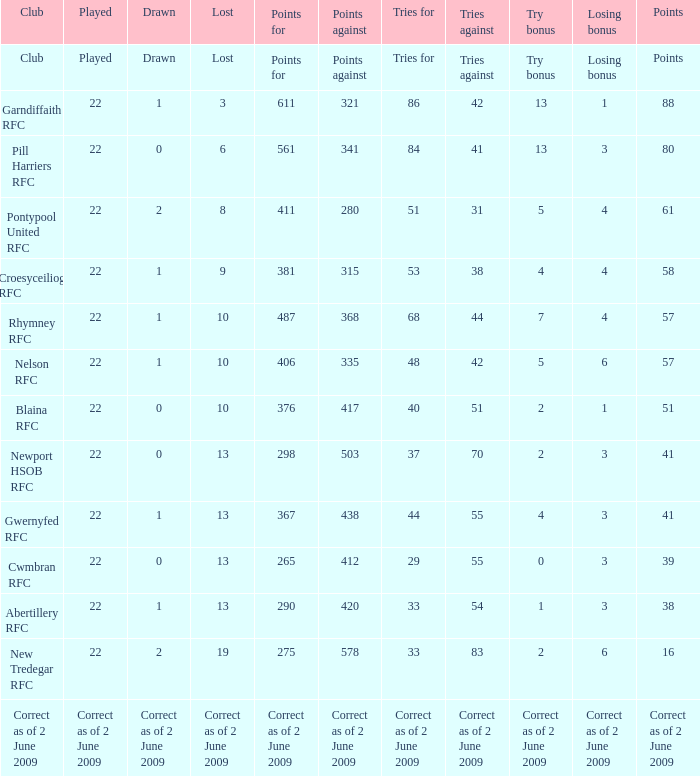How many points against did the club with a losing bonus of 3 and 84 tries have? 341.0. Parse the table in full. {'header': ['Club', 'Played', 'Drawn', 'Lost', 'Points for', 'Points against', 'Tries for', 'Tries against', 'Try bonus', 'Losing bonus', 'Points'], 'rows': [['Club', 'Played', 'Drawn', 'Lost', 'Points for', 'Points against', 'Tries for', 'Tries against', 'Try bonus', 'Losing bonus', 'Points'], ['Garndiffaith RFC', '22', '1', '3', '611', '321', '86', '42', '13', '1', '88'], ['Pill Harriers RFC', '22', '0', '6', '561', '341', '84', '41', '13', '3', '80'], ['Pontypool United RFC', '22', '2', '8', '411', '280', '51', '31', '5', '4', '61'], ['Croesyceiliog RFC', '22', '1', '9', '381', '315', '53', '38', '4', '4', '58'], ['Rhymney RFC', '22', '1', '10', '487', '368', '68', '44', '7', '4', '57'], ['Nelson RFC', '22', '1', '10', '406', '335', '48', '42', '5', '6', '57'], ['Blaina RFC', '22', '0', '10', '376', '417', '40', '51', '2', '1', '51'], ['Newport HSOB RFC', '22', '0', '13', '298', '503', '37', '70', '2', '3', '41'], ['Gwernyfed RFC', '22', '1', '13', '367', '438', '44', '55', '4', '3', '41'], ['Cwmbran RFC', '22', '0', '13', '265', '412', '29', '55', '0', '3', '39'], ['Abertillery RFC', '22', '1', '13', '290', '420', '33', '54', '1', '3', '38'], ['New Tredegar RFC', '22', '2', '19', '275', '578', '33', '83', '2', '6', '16'], ['Correct as of 2 June 2009', 'Correct as of 2 June 2009', 'Correct as of 2 June 2009', 'Correct as of 2 June 2009', 'Correct as of 2 June 2009', 'Correct as of 2 June 2009', 'Correct as of 2 June 2009', 'Correct as of 2 June 2009', 'Correct as of 2 June 2009', 'Correct as of 2 June 2009', 'Correct as of 2 June 2009']]} 